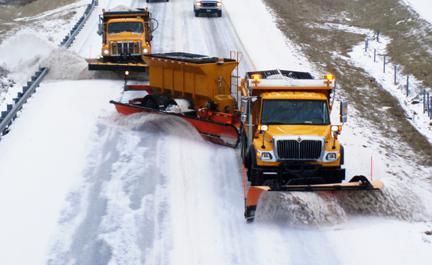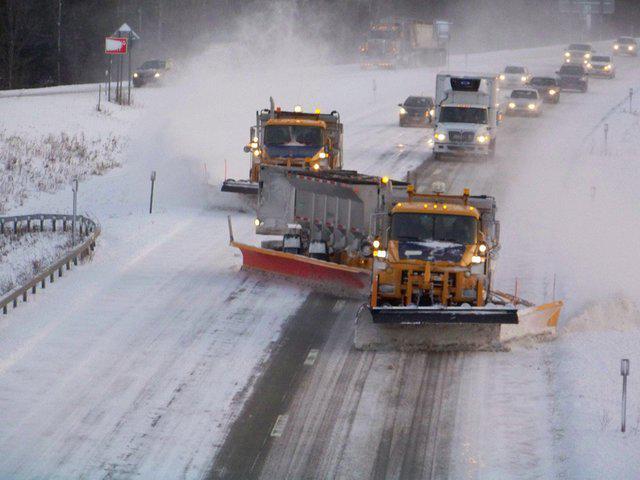The first image is the image on the left, the second image is the image on the right. Assess this claim about the two images: "There are two pick up trucks with a solid colored snow plow attached plowing snow.". Correct or not? Answer yes or no. No. 